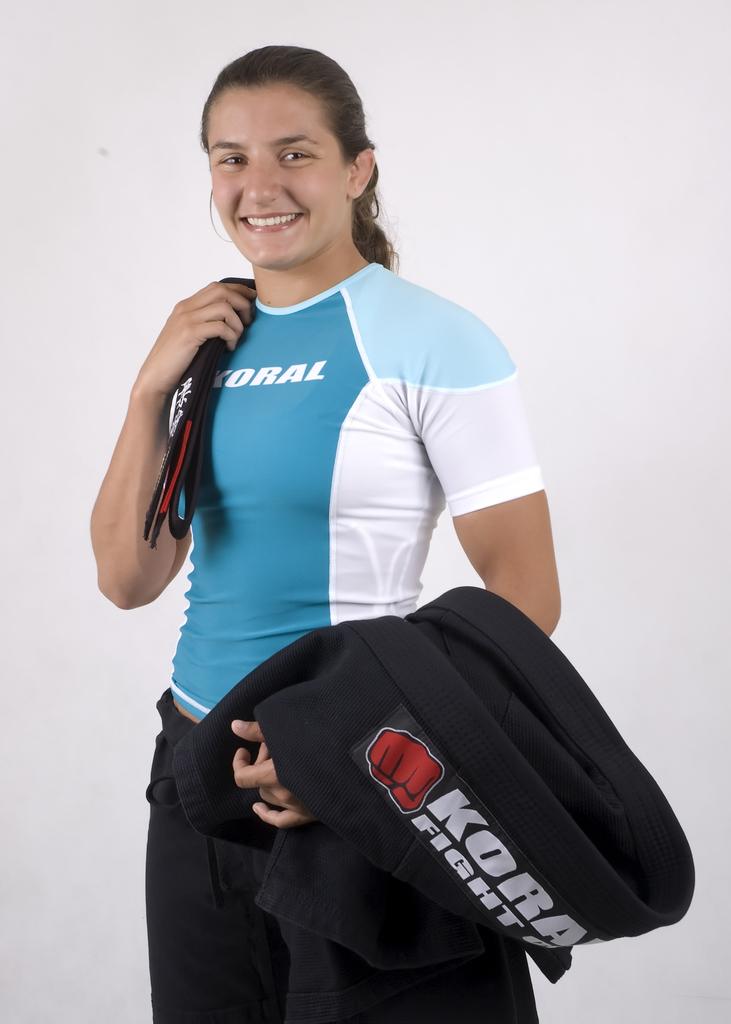What is the brand of gear worn here?
Your answer should be very brief. Koral. What does her shirt say?
Ensure brevity in your answer.  Koral. 